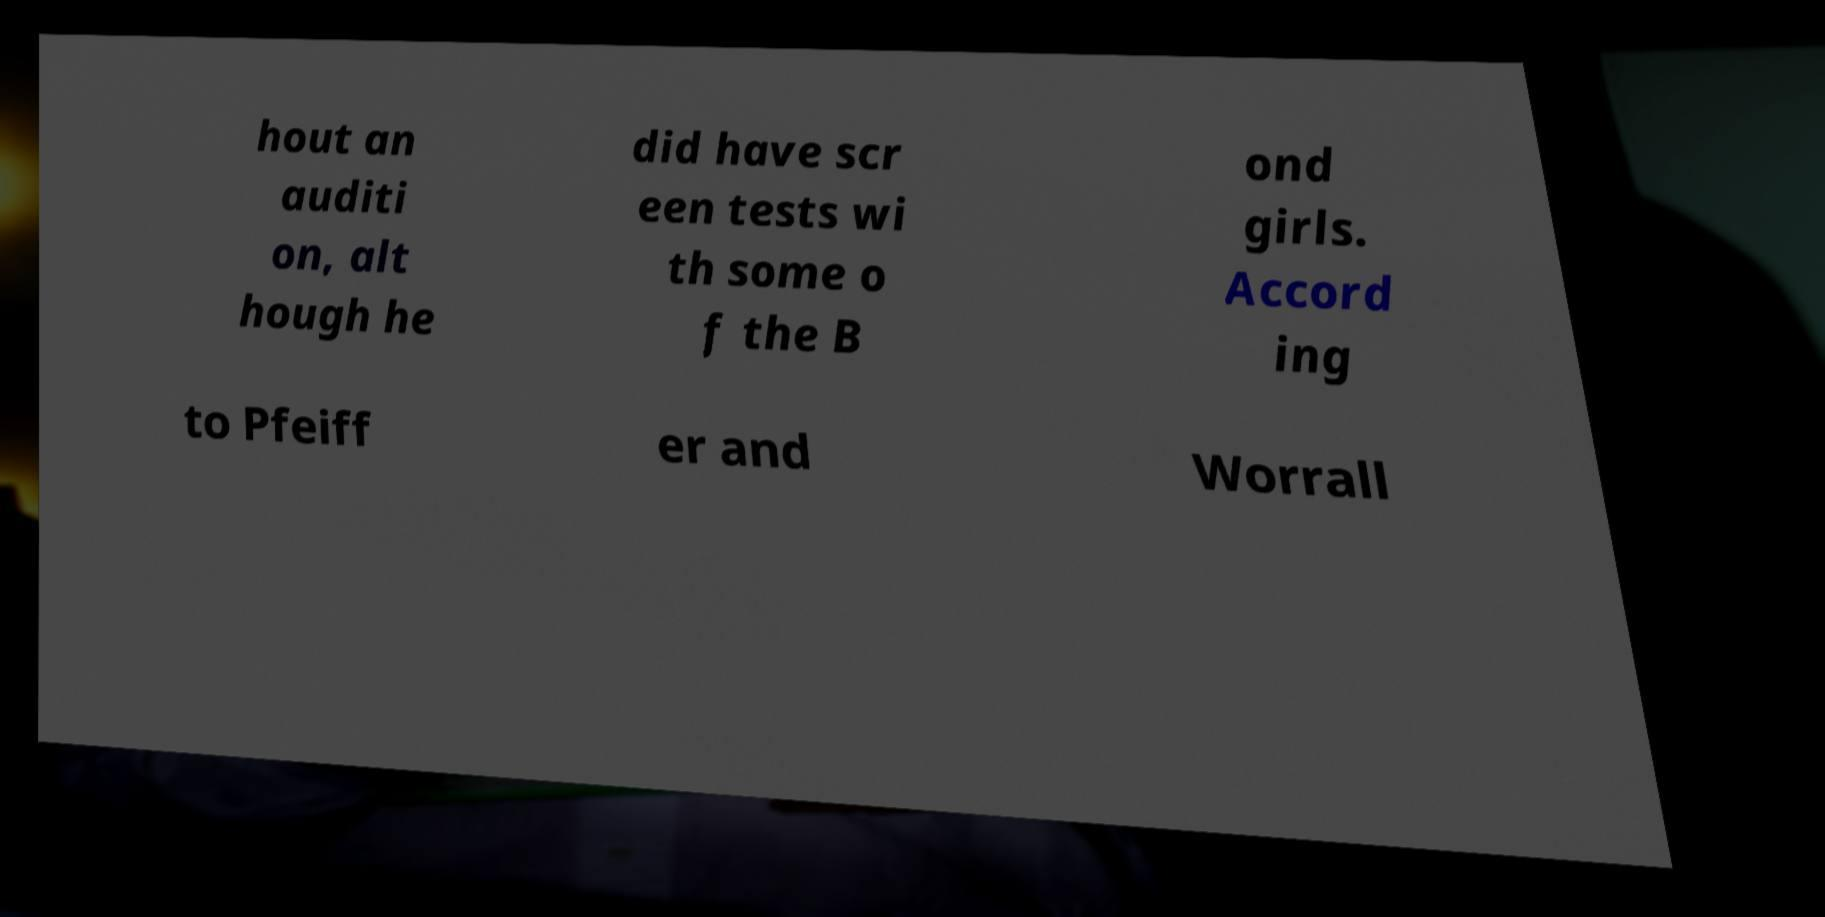Can you read and provide the text displayed in the image?This photo seems to have some interesting text. Can you extract and type it out for me? hout an auditi on, alt hough he did have scr een tests wi th some o f the B ond girls. Accord ing to Pfeiff er and Worrall 